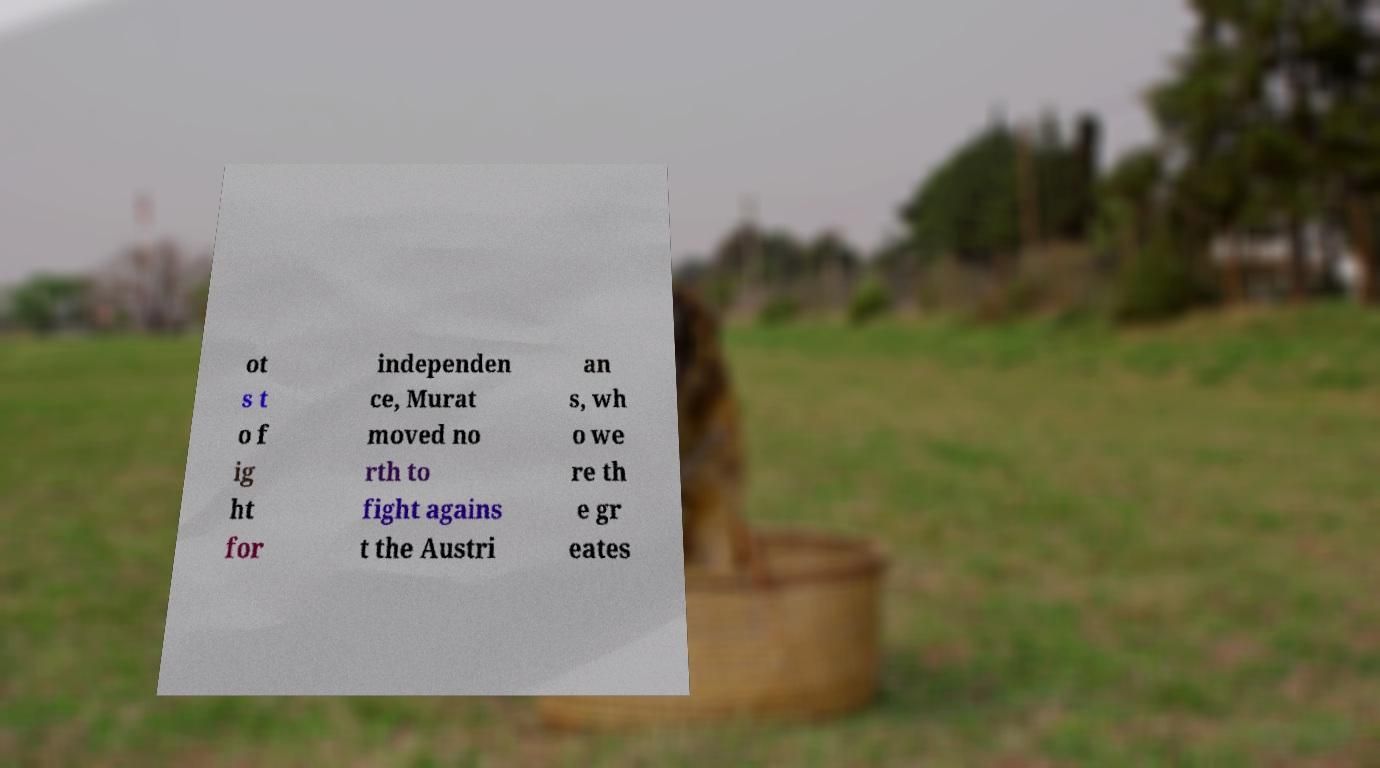What messages or text are displayed in this image? I need them in a readable, typed format. ot s t o f ig ht for independen ce, Murat moved no rth to fight agains t the Austri an s, wh o we re th e gr eates 